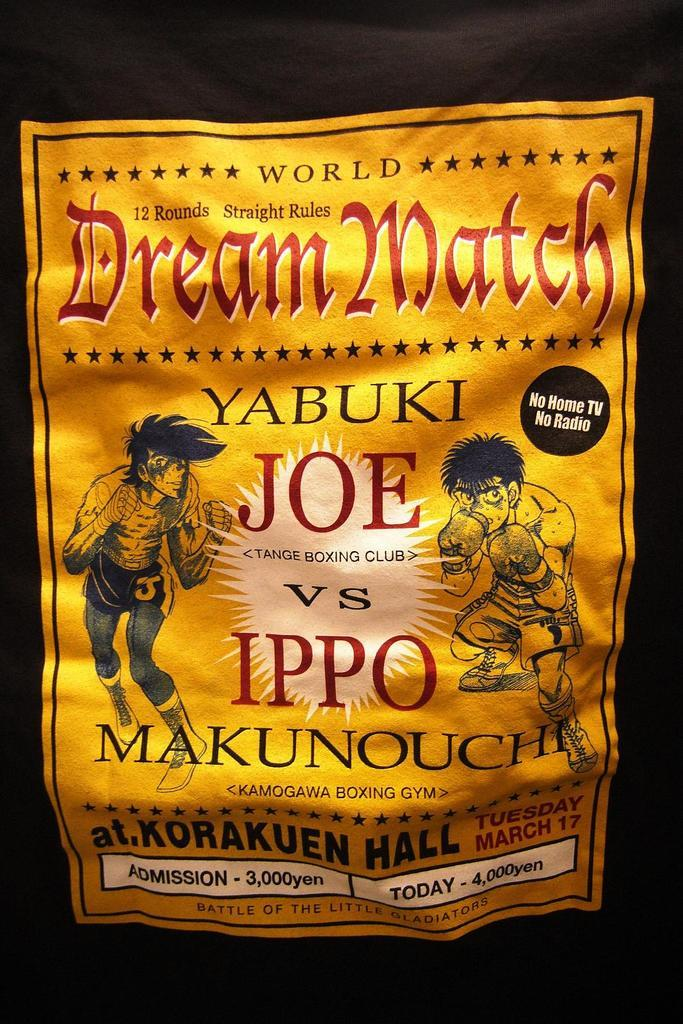<image>
Summarize the visual content of the image. A World Dream Match event is advertised for today.. 